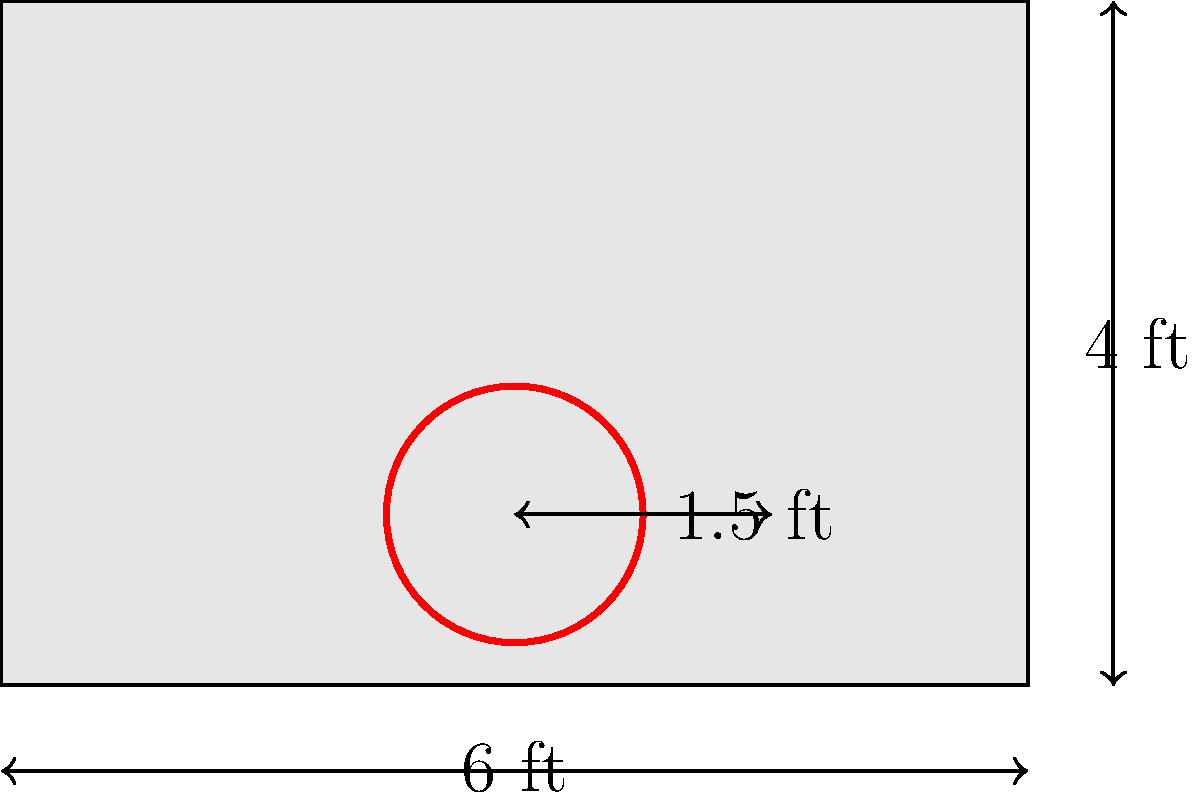You're sizing up a new court for a streetball challenge. The backboard measures 6 feet wide and 4 feet tall, with a circular hoop of 1.5 feet in diameter attached to it. What's the total surface area of the backboard and the front face of the hoop rim combined? Round your answer to the nearest square foot. Let's break this down step-by-step:

1. Calculate the area of the backboard:
   Area of backboard = length × width
   $A_b = 6 \text{ ft} \times 4 \text{ ft} = 24 \text{ sq ft}$

2. Calculate the area of the hoop rim:
   The hoop is a circle, so we need to find the circumference (outer edge) and multiply by the thickness.
   Diameter of the hoop = 1.5 ft
   Radius of the hoop = 1.5 ft ÷ 2 = 0.75 ft
   
   Circumference of the hoop = $2\pi r$
   $C = 2\pi(0.75 \text{ ft}) \approx 4.71 \text{ ft}$
   
   Assuming a standard rim thickness of about 0.5 inches (0.0417 ft):
   Area of hoop rim = $4.71 \text{ ft} \times 0.0417 \text{ ft} \approx 0.196 \text{ sq ft}$

3. Total surface area:
   Total area = Area of backboard + Area of hoop rim
   $A_{\text{total}} = 24 \text{ sq ft} + 0.196 \text{ sq ft} \approx 24.196 \text{ sq ft}$

4. Rounding to the nearest square foot:
   $24.196 \text{ sq ft} \approx 24 \text{ sq ft}$
Answer: 24 sq ft 